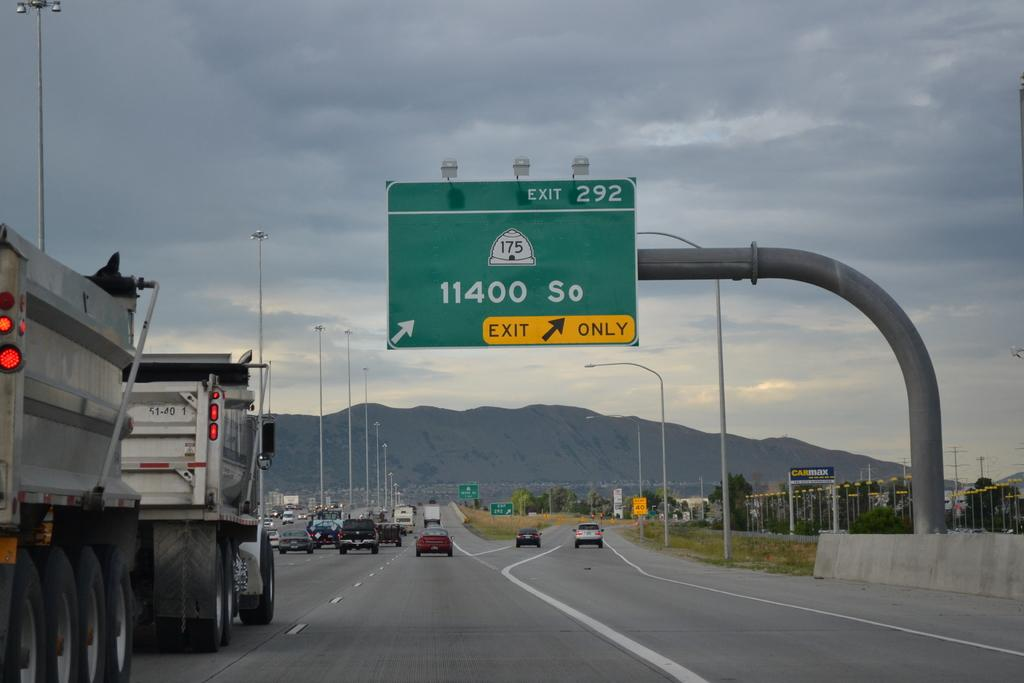<image>
Summarize the visual content of the image. An exit sign on a highway for exit 292 is hanging overhead. 